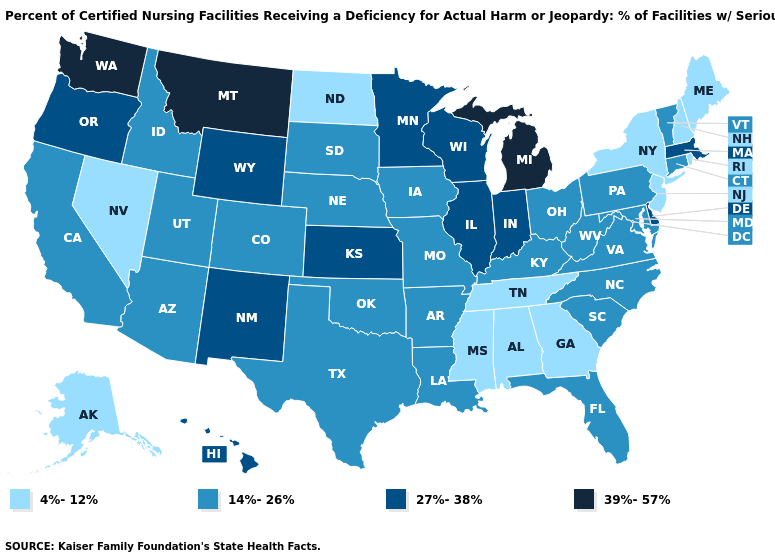Which states have the highest value in the USA?
Keep it brief. Michigan, Montana, Washington. What is the highest value in states that border Maryland?
Quick response, please. 27%-38%. Name the states that have a value in the range 14%-26%?
Quick response, please. Arizona, Arkansas, California, Colorado, Connecticut, Florida, Idaho, Iowa, Kentucky, Louisiana, Maryland, Missouri, Nebraska, North Carolina, Ohio, Oklahoma, Pennsylvania, South Carolina, South Dakota, Texas, Utah, Vermont, Virginia, West Virginia. What is the lowest value in the USA?
Be succinct. 4%-12%. Which states have the highest value in the USA?
Answer briefly. Michigan, Montana, Washington. Name the states that have a value in the range 27%-38%?
Give a very brief answer. Delaware, Hawaii, Illinois, Indiana, Kansas, Massachusetts, Minnesota, New Mexico, Oregon, Wisconsin, Wyoming. Which states have the lowest value in the USA?
Quick response, please. Alabama, Alaska, Georgia, Maine, Mississippi, Nevada, New Hampshire, New Jersey, New York, North Dakota, Rhode Island, Tennessee. What is the highest value in states that border Kansas?
Be succinct. 14%-26%. What is the highest value in the West ?
Write a very short answer. 39%-57%. Does Washington have a higher value than Montana?
Concise answer only. No. What is the highest value in the USA?
Answer briefly. 39%-57%. Does the first symbol in the legend represent the smallest category?
Keep it brief. Yes. Does Michigan have the lowest value in the MidWest?
Answer briefly. No. Among the states that border Washington , which have the lowest value?
Answer briefly. Idaho. Which states have the lowest value in the USA?
Concise answer only. Alabama, Alaska, Georgia, Maine, Mississippi, Nevada, New Hampshire, New Jersey, New York, North Dakota, Rhode Island, Tennessee. 